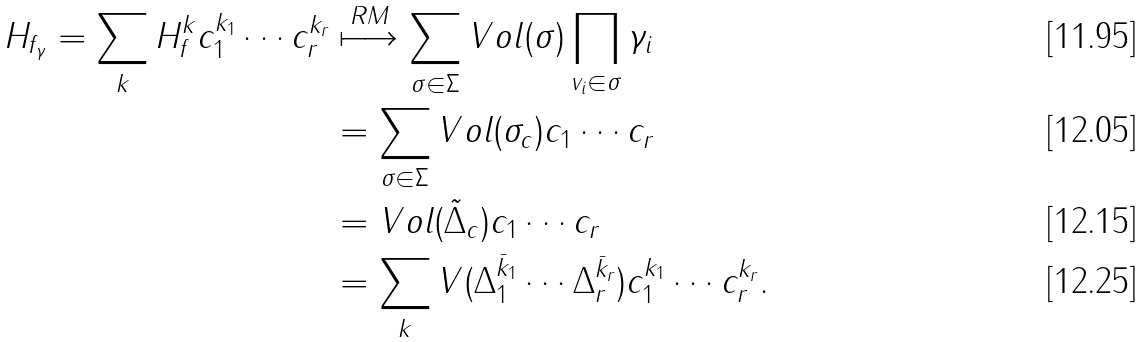Convert formula to latex. <formula><loc_0><loc_0><loc_500><loc_500>H _ { f _ { \gamma } } = \sum _ { k } H _ { f } ^ { k } c _ { 1 } ^ { k _ { 1 } } \cdots c _ { r } ^ { k _ { r } } & \stackrel { R M } { \longmapsto } \sum _ { \sigma \in \Sigma } V o l ( \sigma ) \prod _ { v _ { i } \in \sigma } \gamma _ { i } \\ & = \sum _ { \sigma \in \Sigma } V o l ( \sigma _ { c } ) c _ { 1 } \cdots c _ { r } \\ & = V o l ( \tilde { \Delta } _ { c } ) c _ { 1 } \cdots c _ { r } \\ & = \sum _ { k } V ( \Delta _ { 1 } ^ { \bar { k } _ { 1 } } \cdots \Delta _ { r } ^ { \bar { k } _ { r } } ) c _ { 1 } ^ { k _ { 1 } } \cdots c _ { r } ^ { k _ { r } } .</formula> 